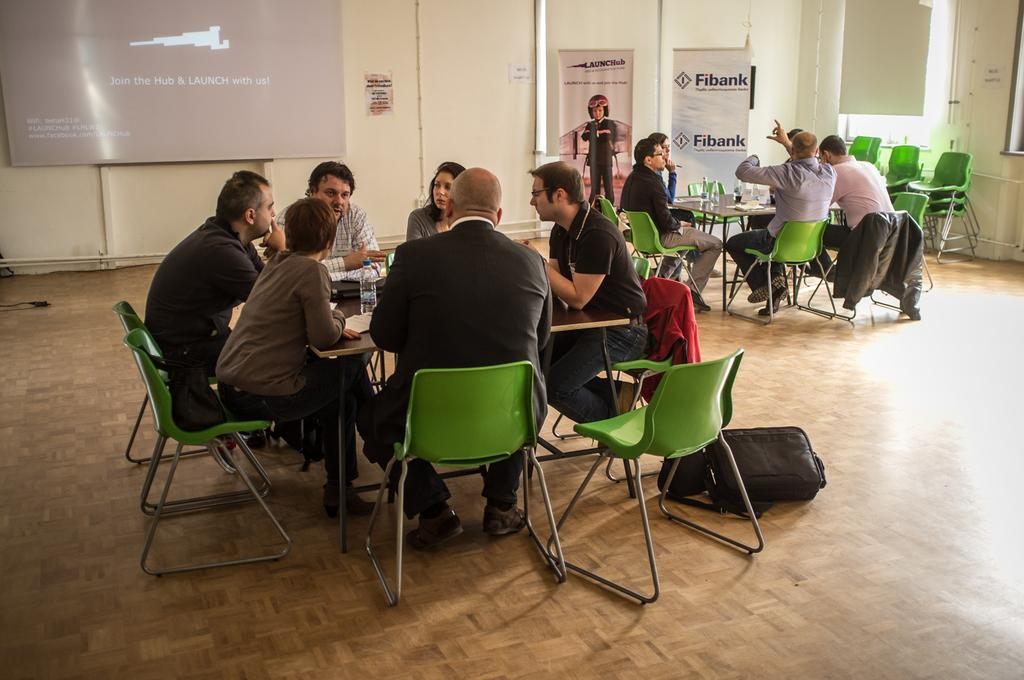What are the people in the image doing? The people in the image are sitting on chairs. What is present in the image besides the people? There is a table in the image. What can be seen on the table? There is a water bottle on the table. Are there any other people in the image? Yes, there are people sitting at the other side of the table. How many rats are sitting on the chairs in the image? There are no rats present in the image; only people are sitting on the chairs. 